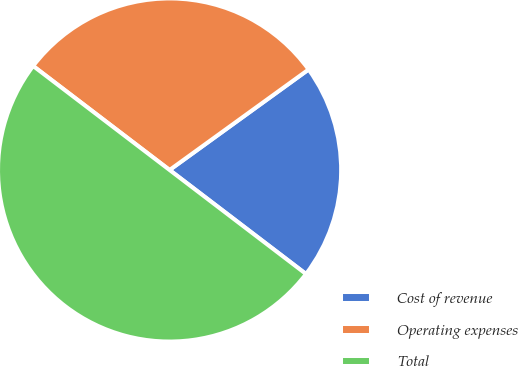Convert chart to OTSL. <chart><loc_0><loc_0><loc_500><loc_500><pie_chart><fcel>Cost of revenue<fcel>Operating expenses<fcel>Total<nl><fcel>20.33%<fcel>29.67%<fcel>50.0%<nl></chart> 